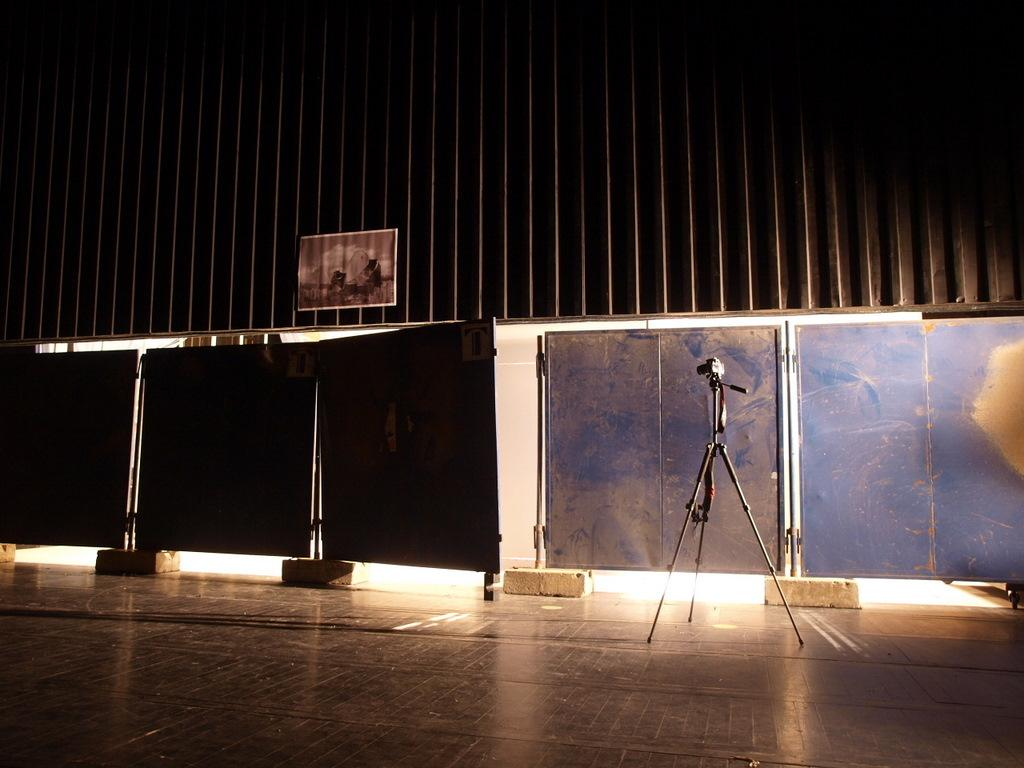What type of location is depicted in the image? The image appears to depict a hall. What can be seen hanging on the wall in the image? There is a poster in the image. What material is present in the image that is used for construction or covering? There are metal sheets in the image. What device is used for recording or capturing video in the image? A video camera is mounted on a stand in the image. What type of activity is taking place in the hall in the image? The image does not depict any specific activity taking place in the hall. How quiet is the hall in the image? The image does not provide any information about the noise level or quietness of the hall. 